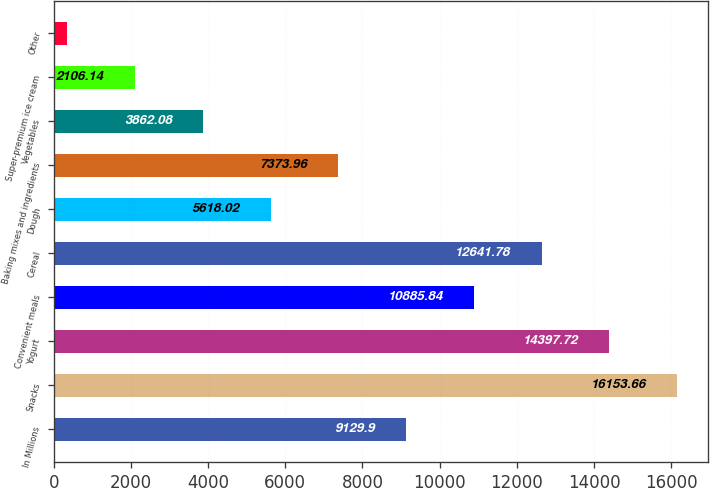Convert chart to OTSL. <chart><loc_0><loc_0><loc_500><loc_500><bar_chart><fcel>In Millions<fcel>Snacks<fcel>Yogurt<fcel>Convenient meals<fcel>Cereal<fcel>Dough<fcel>Baking mixes and ingredients<fcel>Vegetables<fcel>Super-premium ice cream<fcel>Other<nl><fcel>9129.9<fcel>16153.7<fcel>14397.7<fcel>10885.8<fcel>12641.8<fcel>5618.02<fcel>7373.96<fcel>3862.08<fcel>2106.14<fcel>350.2<nl></chart> 